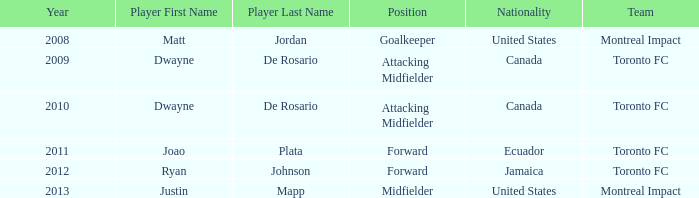What was the player's position when they were justin mapp in articles with hcards category and had a united states nationality? Midfielder. 